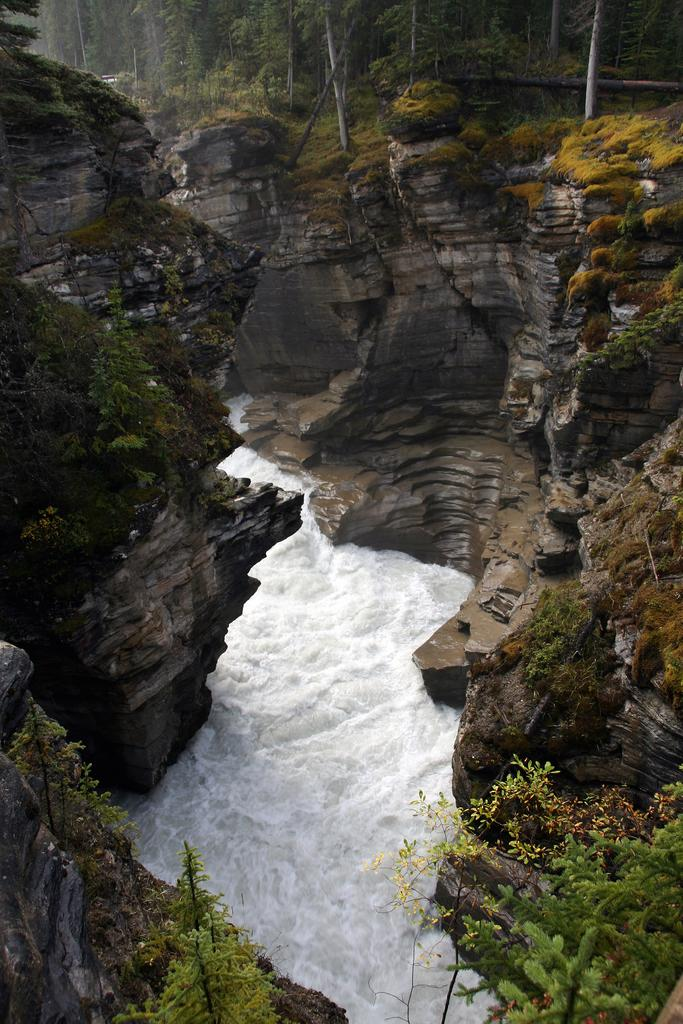What type of natural elements can be seen in the image? There are trees and water visible in the image. Where are the rocks located in the image? There are rocks on both the left and right sides of the image. Reasoning: Let'g: Let's think step by step in order to produce the conversation. We start by identifying the main natural elements in the image, which are trees and water. Then, we focus on the rocks and their locations within the image. Each question is designed to elicit a specific detail about the image that is known from the provided facts. Absurd Question/Answer: What type of marble is present in the image? There is no marble present in the image; it features natural elements such as trees, water, and rocks. What is the aftermath of the event depicted in the image? There is no event depicted in the image, as it features natural elements such as trees, water, and rocks. 